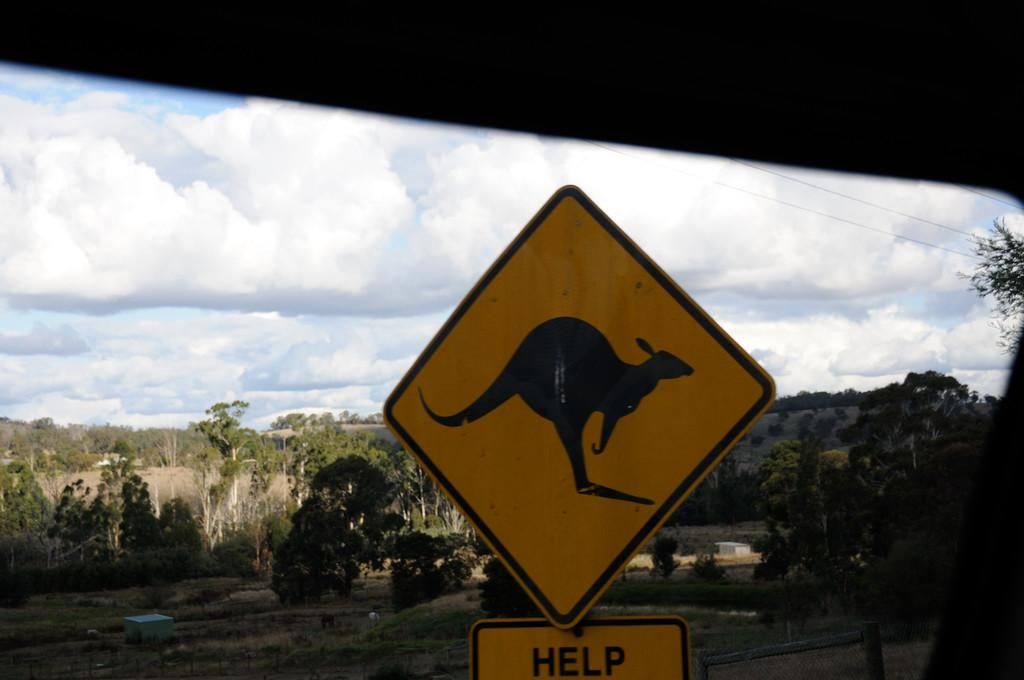<image>
Offer a succinct explanation of the picture presented. A yellow sign with a kangaroo pictured with the word Help written below. 